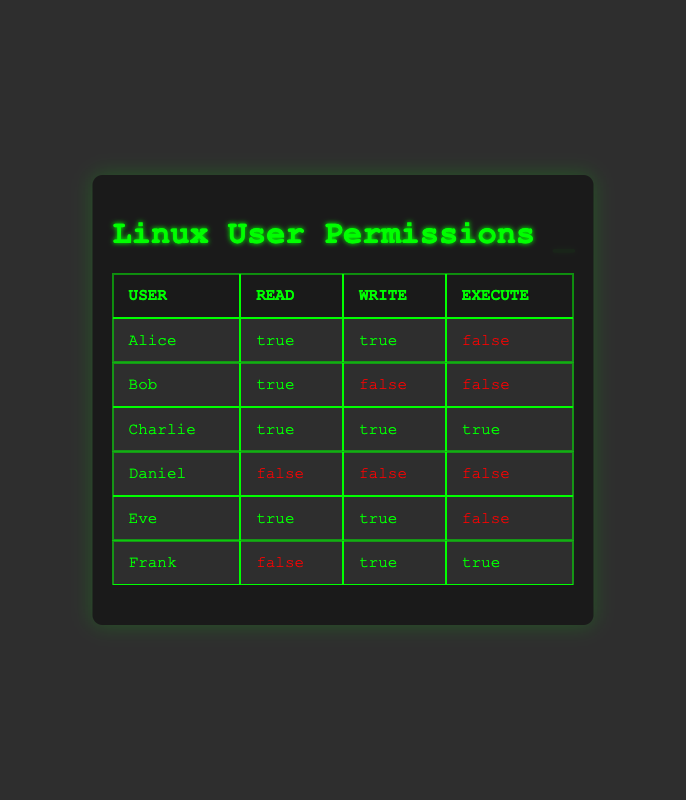What permissions does Alice have? According to the table, Alice has "Read" permission set to true, "Write" permission also set to true, and "Execute" permission set to false. Therefore, Alice can read and write, but cannot execute.
Answer: Read: true, Write: true, Execute: false Who has the permission to execute files? To answer this, we look for users with "Execute" permission set to true. From the table, Charlie has all permissions, while Frank has only the execute permission set to true. Therefore, Charlie and Frank can execute files.
Answer: Charlie and Frank Is Daniel allowed to read, write, or execute files? The table shows that Daniel has all permissions set to false. Thus, he is not allowed to read, write, or execute any files.
Answer: No How many users have write permission? We check the "Write" column and find that Alice, Charlie, Eve, and Frank all have "Write" permission set to true. Counting these gives us four users.
Answer: 4 What is the average number of permissions (Read, Write, Execute) granted to each user? There are a total of 6 users. We can count each permission status as 1 for true and 0 for false. Summing the permissions gives (2 + 1 + 3 + 0 + 2 + 2) = 10. Now, dividing by 6 users gives an average of 10/6, which simplifies to approximately 1.67.
Answer: 1.67 Which user has the most permissions? By looking at the total permissions granted, we see Charlie has 3 (Read, Write, Execute as true). Alice and Eve both have 2 true permissions, while others have fewer. Thus, Charlie is the user with the most permissions.
Answer: Charlie Can Bob execute files? The table shows that Bob's "Execute" permission is set to false. Therefore, he cannot execute files.
Answer: No Which permission is the least granted among users? Assessing the table, we see the "Execute" permission occurs less frequently as most users have this set to false. Out of 6 users, only Charlie and Frank have this permission set to true, indicating it is the least granted.
Answer: Execute permission 